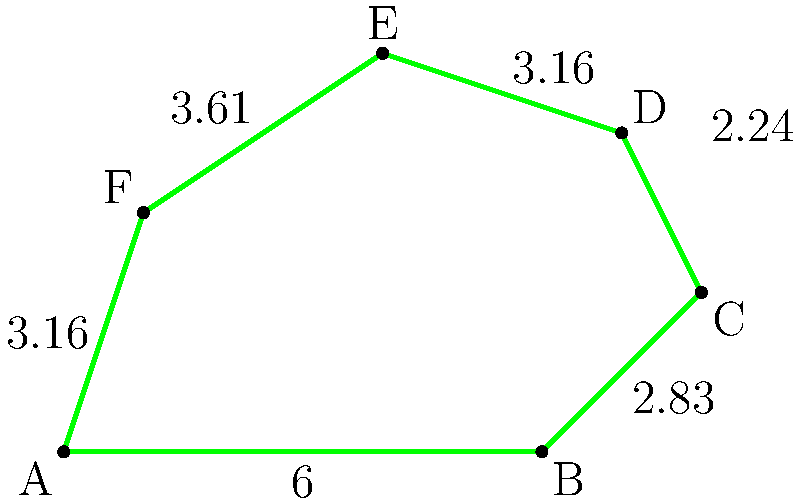A manufacturing complex has allocated an irregularly shaped green space represented by the polygon ABCDEF. Given that the lengths of the sides are AB = 6 units, BC ≈ 2.83 units, CD ≈ 2.24 units, DE ≈ 3.16 units, EF ≈ 3.61 units, and FA ≈ 3.16 units, calculate the perimeter of this green space. How does this calculation relate to potential subsidies for green spaces in manufacturing areas? To calculate the perimeter of the irregularly shaped green space, we need to sum up the lengths of all sides of the polygon ABCDEF. Here's the step-by-step process:

1. Identify the lengths of each side:
   AB = 6 units
   BC ≈ 2.83 units
   CD ≈ 2.24 units
   DE ≈ 3.16 units
   EF ≈ 3.61 units
   FA ≈ 3.16 units

2. Add all the side lengths:
   Perimeter = AB + BC + CD + DE + EF + FA
   Perimeter ≈ 6 + 2.83 + 2.24 + 3.16 + 3.61 + 3.16

3. Calculate the sum:
   Perimeter ≈ 21 units

This calculation is relevant to potential subsidies for green spaces in manufacturing areas because:

1. Many environmental subsidy programs consider the size of green spaces when determining funding amounts.
2. The perimeter can be used to estimate the amount of native plants or trees needed for bordering the green space, which may be eligible for specific grants.
3. Some regulations may require a minimum perimeter or area for green spaces in industrial zones, and this calculation helps ensure compliance.
4. The perimeter can be used to calculate fencing or pathway costs, which might be covered by certain green infrastructure grants.
Answer: The perimeter is approximately 21 units, which can be used to determine eligible subsidies and ensure compliance with green space regulations in manufacturing areas. 